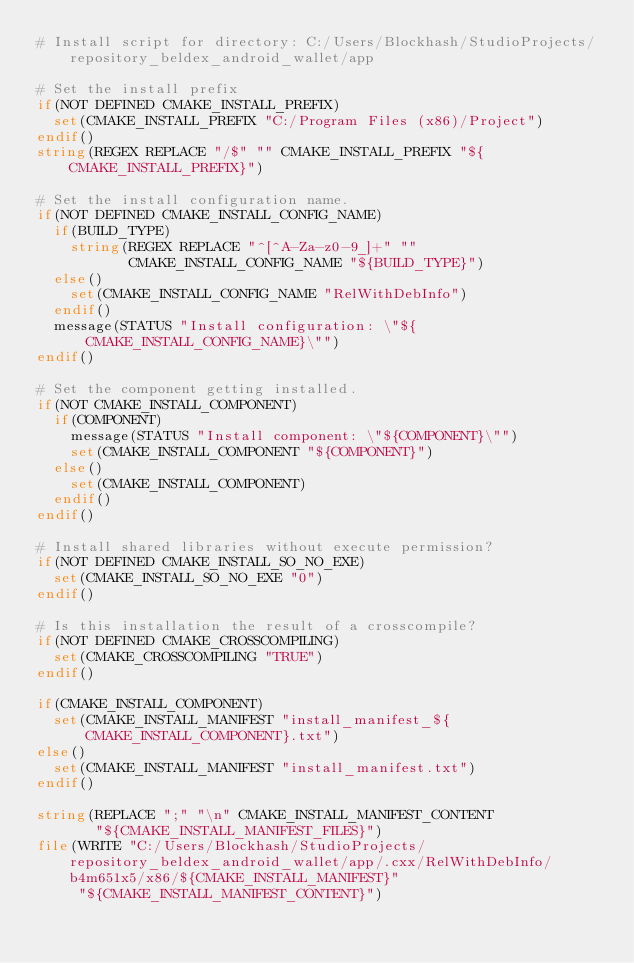<code> <loc_0><loc_0><loc_500><loc_500><_CMake_># Install script for directory: C:/Users/Blockhash/StudioProjects/repository_beldex_android_wallet/app

# Set the install prefix
if(NOT DEFINED CMAKE_INSTALL_PREFIX)
  set(CMAKE_INSTALL_PREFIX "C:/Program Files (x86)/Project")
endif()
string(REGEX REPLACE "/$" "" CMAKE_INSTALL_PREFIX "${CMAKE_INSTALL_PREFIX}")

# Set the install configuration name.
if(NOT DEFINED CMAKE_INSTALL_CONFIG_NAME)
  if(BUILD_TYPE)
    string(REGEX REPLACE "^[^A-Za-z0-9_]+" ""
           CMAKE_INSTALL_CONFIG_NAME "${BUILD_TYPE}")
  else()
    set(CMAKE_INSTALL_CONFIG_NAME "RelWithDebInfo")
  endif()
  message(STATUS "Install configuration: \"${CMAKE_INSTALL_CONFIG_NAME}\"")
endif()

# Set the component getting installed.
if(NOT CMAKE_INSTALL_COMPONENT)
  if(COMPONENT)
    message(STATUS "Install component: \"${COMPONENT}\"")
    set(CMAKE_INSTALL_COMPONENT "${COMPONENT}")
  else()
    set(CMAKE_INSTALL_COMPONENT)
  endif()
endif()

# Install shared libraries without execute permission?
if(NOT DEFINED CMAKE_INSTALL_SO_NO_EXE)
  set(CMAKE_INSTALL_SO_NO_EXE "0")
endif()

# Is this installation the result of a crosscompile?
if(NOT DEFINED CMAKE_CROSSCOMPILING)
  set(CMAKE_CROSSCOMPILING "TRUE")
endif()

if(CMAKE_INSTALL_COMPONENT)
  set(CMAKE_INSTALL_MANIFEST "install_manifest_${CMAKE_INSTALL_COMPONENT}.txt")
else()
  set(CMAKE_INSTALL_MANIFEST "install_manifest.txt")
endif()

string(REPLACE ";" "\n" CMAKE_INSTALL_MANIFEST_CONTENT
       "${CMAKE_INSTALL_MANIFEST_FILES}")
file(WRITE "C:/Users/Blockhash/StudioProjects/repository_beldex_android_wallet/app/.cxx/RelWithDebInfo/b4m651x5/x86/${CMAKE_INSTALL_MANIFEST}"
     "${CMAKE_INSTALL_MANIFEST_CONTENT}")
</code> 